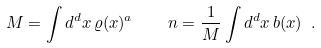Convert formula to latex. <formula><loc_0><loc_0><loc_500><loc_500>M = \int d ^ { d } x \, \varrho ( x ) ^ { a } \quad n = \frac { 1 } { M } \int d ^ { d } x \, b ( x ) \ .</formula> 